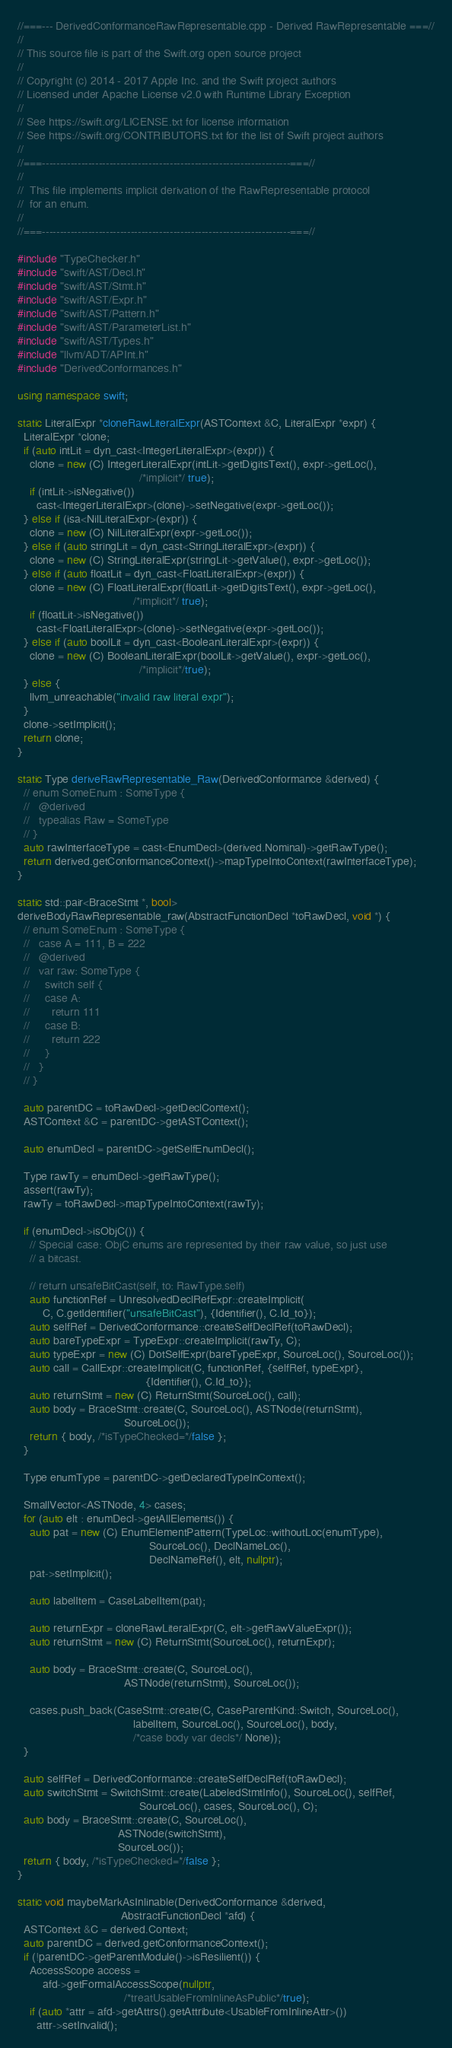Convert code to text. <code><loc_0><loc_0><loc_500><loc_500><_C++_>//===--- DerivedConformanceRawRepresentable.cpp - Derived RawRepresentable ===//
//
// This source file is part of the Swift.org open source project
//
// Copyright (c) 2014 - 2017 Apple Inc. and the Swift project authors
// Licensed under Apache License v2.0 with Runtime Library Exception
//
// See https://swift.org/LICENSE.txt for license information
// See https://swift.org/CONTRIBUTORS.txt for the list of Swift project authors
//
//===----------------------------------------------------------------------===//
//
//  This file implements implicit derivation of the RawRepresentable protocol
//  for an enum.
//
//===----------------------------------------------------------------------===//

#include "TypeChecker.h"
#include "swift/AST/Decl.h"
#include "swift/AST/Stmt.h"
#include "swift/AST/Expr.h"
#include "swift/AST/Pattern.h"
#include "swift/AST/ParameterList.h"
#include "swift/AST/Types.h"
#include "llvm/ADT/APInt.h"
#include "DerivedConformances.h"

using namespace swift;

static LiteralExpr *cloneRawLiteralExpr(ASTContext &C, LiteralExpr *expr) {
  LiteralExpr *clone;
  if (auto intLit = dyn_cast<IntegerLiteralExpr>(expr)) {
    clone = new (C) IntegerLiteralExpr(intLit->getDigitsText(), expr->getLoc(),
                                       /*implicit*/ true);
    if (intLit->isNegative())
      cast<IntegerLiteralExpr>(clone)->setNegative(expr->getLoc());
  } else if (isa<NilLiteralExpr>(expr)) {
    clone = new (C) NilLiteralExpr(expr->getLoc());
  } else if (auto stringLit = dyn_cast<StringLiteralExpr>(expr)) {
    clone = new (C) StringLiteralExpr(stringLit->getValue(), expr->getLoc());
  } else if (auto floatLit = dyn_cast<FloatLiteralExpr>(expr)) {
    clone = new (C) FloatLiteralExpr(floatLit->getDigitsText(), expr->getLoc(),
                                     /*implicit*/ true);
    if (floatLit->isNegative())
      cast<FloatLiteralExpr>(clone)->setNegative(expr->getLoc());
  } else if (auto boolLit = dyn_cast<BooleanLiteralExpr>(expr)) {
    clone = new (C) BooleanLiteralExpr(boolLit->getValue(), expr->getLoc(),
                                       /*implicit*/true);
  } else {
    llvm_unreachable("invalid raw literal expr");
  }
  clone->setImplicit();
  return clone;
}

static Type deriveRawRepresentable_Raw(DerivedConformance &derived) {
  // enum SomeEnum : SomeType {
  //   @derived
  //   typealias Raw = SomeType
  // }
  auto rawInterfaceType = cast<EnumDecl>(derived.Nominal)->getRawType();
  return derived.getConformanceContext()->mapTypeIntoContext(rawInterfaceType);
}

static std::pair<BraceStmt *, bool>
deriveBodyRawRepresentable_raw(AbstractFunctionDecl *toRawDecl, void *) {
  // enum SomeEnum : SomeType {
  //   case A = 111, B = 222
  //   @derived
  //   var raw: SomeType {
  //     switch self {
  //     case A:
  //       return 111
  //     case B:
  //       return 222
  //     }
  //   }
  // }

  auto parentDC = toRawDecl->getDeclContext();
  ASTContext &C = parentDC->getASTContext();

  auto enumDecl = parentDC->getSelfEnumDecl();

  Type rawTy = enumDecl->getRawType();
  assert(rawTy);
  rawTy = toRawDecl->mapTypeIntoContext(rawTy);

  if (enumDecl->isObjC()) {
    // Special case: ObjC enums are represented by their raw value, so just use
    // a bitcast.

    // return unsafeBitCast(self, to: RawType.self)
    auto functionRef = UnresolvedDeclRefExpr::createImplicit(
        C, C.getIdentifier("unsafeBitCast"), {Identifier(), C.Id_to});
    auto selfRef = DerivedConformance::createSelfDeclRef(toRawDecl);
    auto bareTypeExpr = TypeExpr::createImplicit(rawTy, C);
    auto typeExpr = new (C) DotSelfExpr(bareTypeExpr, SourceLoc(), SourceLoc());
    auto call = CallExpr::createImplicit(C, functionRef, {selfRef, typeExpr},
                                         {Identifier(), C.Id_to});
    auto returnStmt = new (C) ReturnStmt(SourceLoc(), call);
    auto body = BraceStmt::create(C, SourceLoc(), ASTNode(returnStmt),
                                  SourceLoc());
    return { body, /*isTypeChecked=*/false };
  }

  Type enumType = parentDC->getDeclaredTypeInContext();

  SmallVector<ASTNode, 4> cases;
  for (auto elt : enumDecl->getAllElements()) {
    auto pat = new (C) EnumElementPattern(TypeLoc::withoutLoc(enumType),
                                          SourceLoc(), DeclNameLoc(),
                                          DeclNameRef(), elt, nullptr);
    pat->setImplicit();

    auto labelItem = CaseLabelItem(pat);

    auto returnExpr = cloneRawLiteralExpr(C, elt->getRawValueExpr());
    auto returnStmt = new (C) ReturnStmt(SourceLoc(), returnExpr);

    auto body = BraceStmt::create(C, SourceLoc(),
                                  ASTNode(returnStmt), SourceLoc());

    cases.push_back(CaseStmt::create(C, CaseParentKind::Switch, SourceLoc(),
                                     labelItem, SourceLoc(), SourceLoc(), body,
                                     /*case body var decls*/ None));
  }

  auto selfRef = DerivedConformance::createSelfDeclRef(toRawDecl);
  auto switchStmt = SwitchStmt::create(LabeledStmtInfo(), SourceLoc(), selfRef,
                                       SourceLoc(), cases, SourceLoc(), C);
  auto body = BraceStmt::create(C, SourceLoc(),
                                ASTNode(switchStmt),
                                SourceLoc());
  return { body, /*isTypeChecked=*/false };
}

static void maybeMarkAsInlinable(DerivedConformance &derived,
                                 AbstractFunctionDecl *afd) {
  ASTContext &C = derived.Context;
  auto parentDC = derived.getConformanceContext();
  if (!parentDC->getParentModule()->isResilient()) {
    AccessScope access =
        afd->getFormalAccessScope(nullptr,
                                  /*treatUsableFromInlineAsPublic*/true);
    if (auto *attr = afd->getAttrs().getAttribute<UsableFromInlineAttr>())
      attr->setInvalid();</code> 